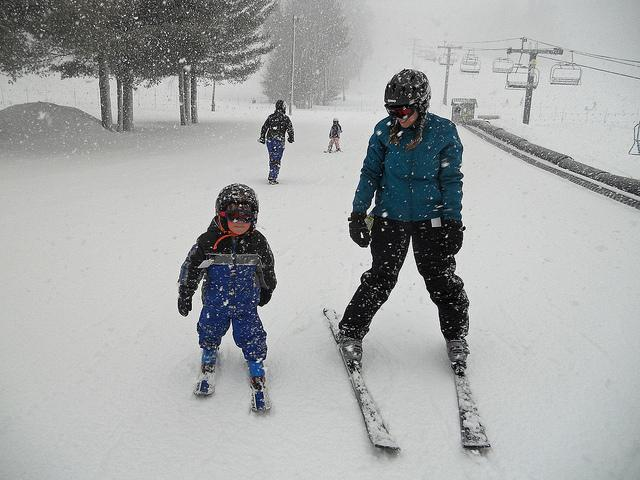What is the contraption on the right used for? carry skiers 